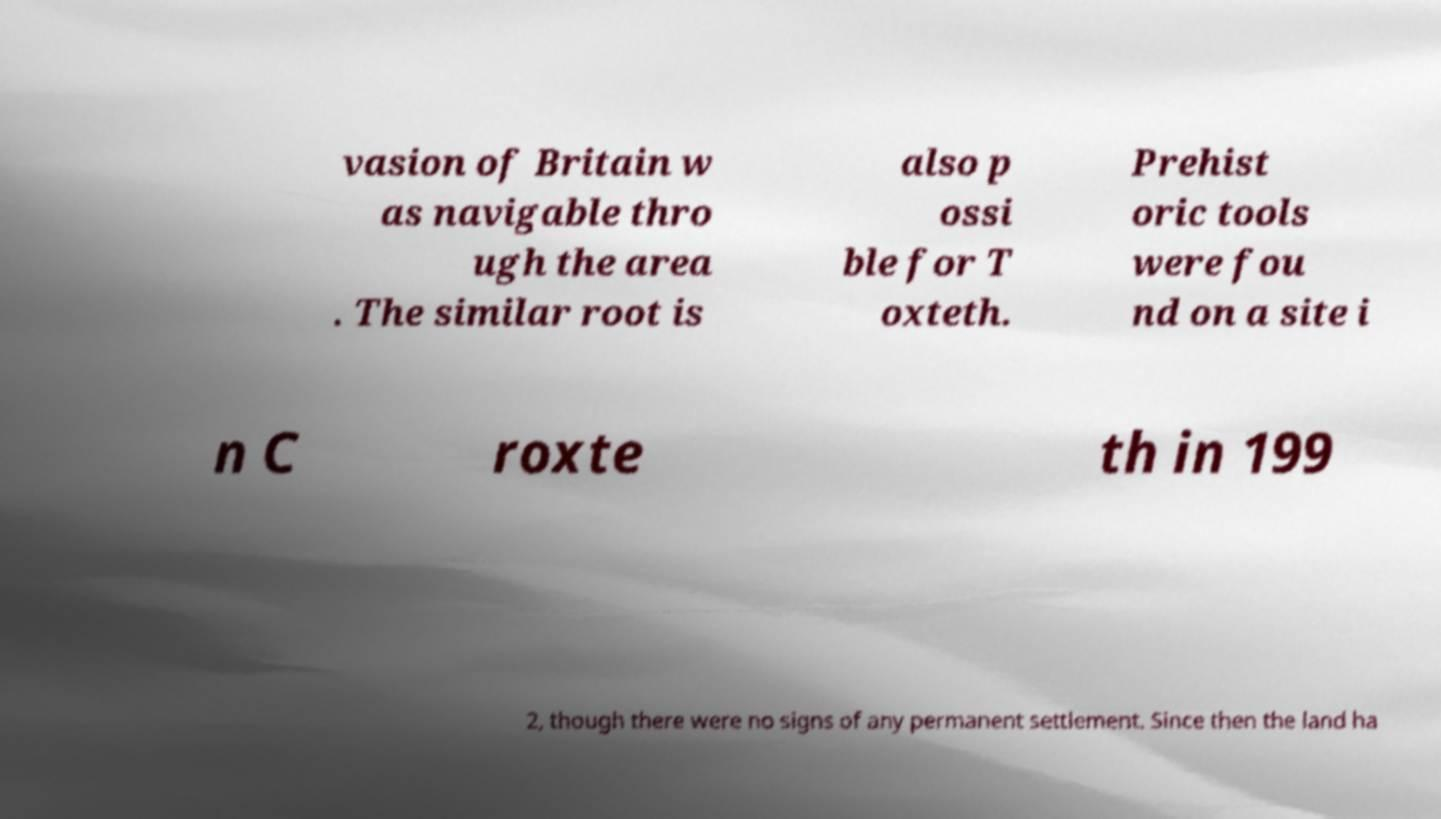Please identify and transcribe the text found in this image. vasion of Britain w as navigable thro ugh the area . The similar root is also p ossi ble for T oxteth. Prehist oric tools were fou nd on a site i n C roxte th in 199 2, though there were no signs of any permanent settlement. Since then the land ha 